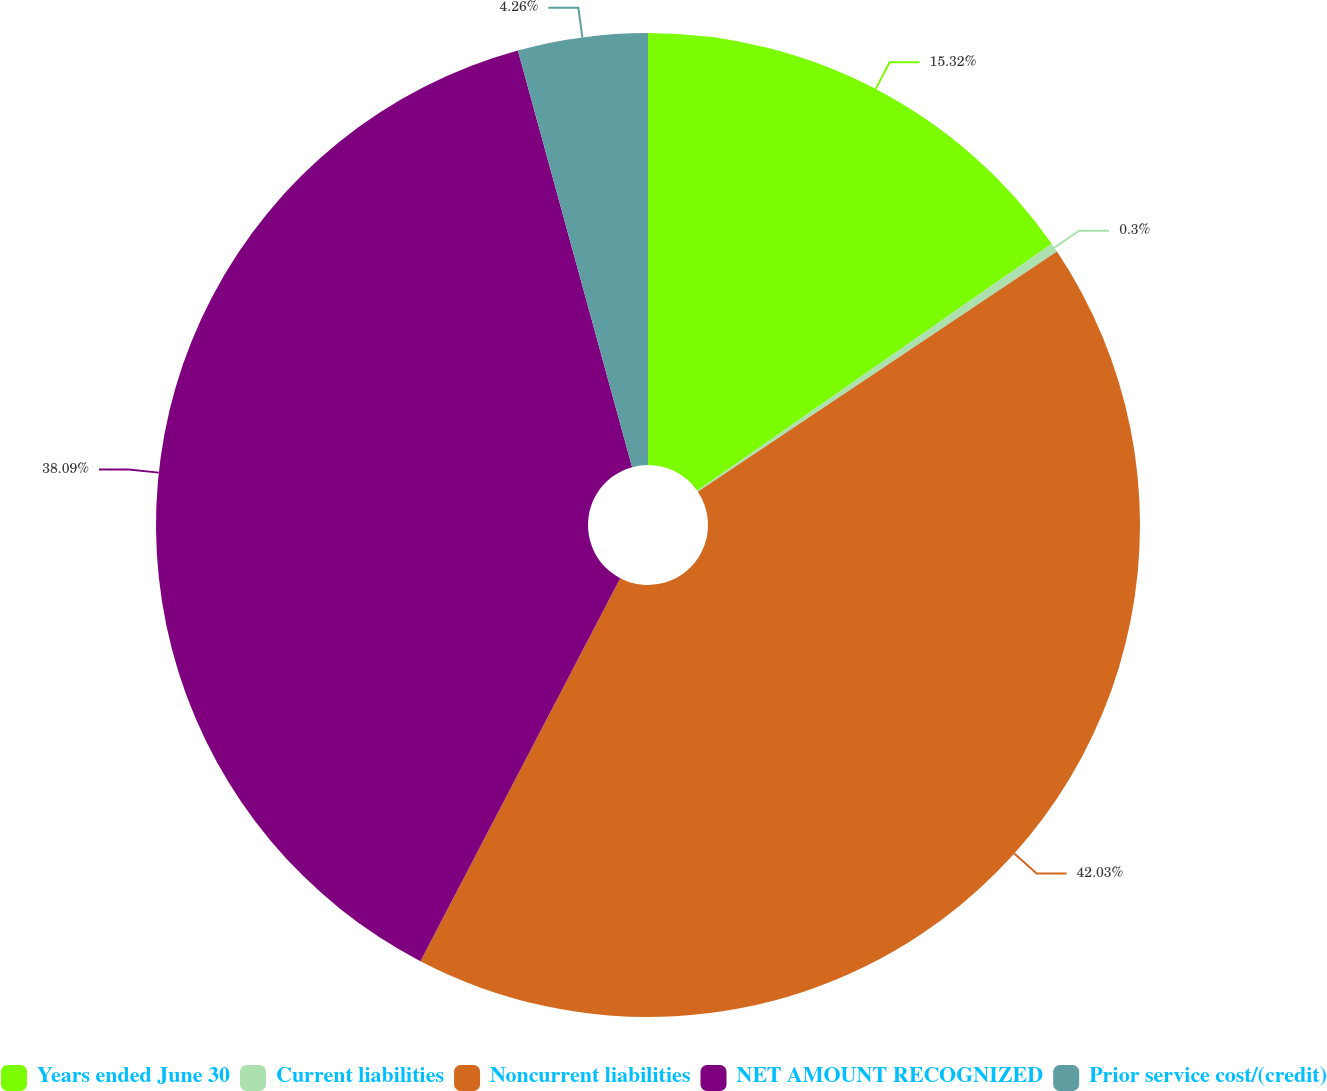<chart> <loc_0><loc_0><loc_500><loc_500><pie_chart><fcel>Years ended June 30<fcel>Current liabilities<fcel>Noncurrent liabilities<fcel>NET AMOUNT RECOGNIZED<fcel>Prior service cost/(credit)<nl><fcel>15.32%<fcel>0.3%<fcel>42.04%<fcel>38.09%<fcel>4.26%<nl></chart> 